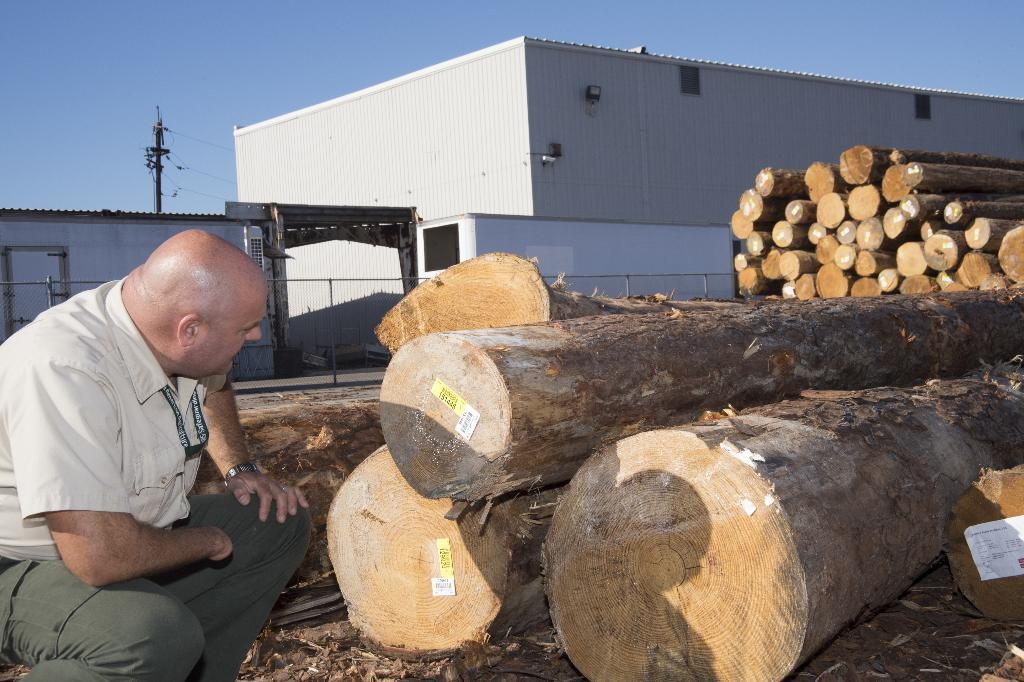What type of tree is present in the image? There is a large tree with bark in the image. What is attached to the tree bark? There are tags on the tree bark. Who is present in the image observing the tree bark? There is a man observing the tree bark. What structures can be seen in the image? There is a building and an electrical pole in the image. How would you describe the sky in the image? The sky is blue and cloudy. What type of apparatus is being used by the man to read the news on the tree bark? There is no apparatus or news present in the image; the man is simply observing the tree bark. What type of rat can be seen climbing the electrical pole in the image? There is no rat present in the image; it only features a large tree, tags on the bark, a man observing the tree, a building, an electrical pole, and a blue and cloudy sky. 